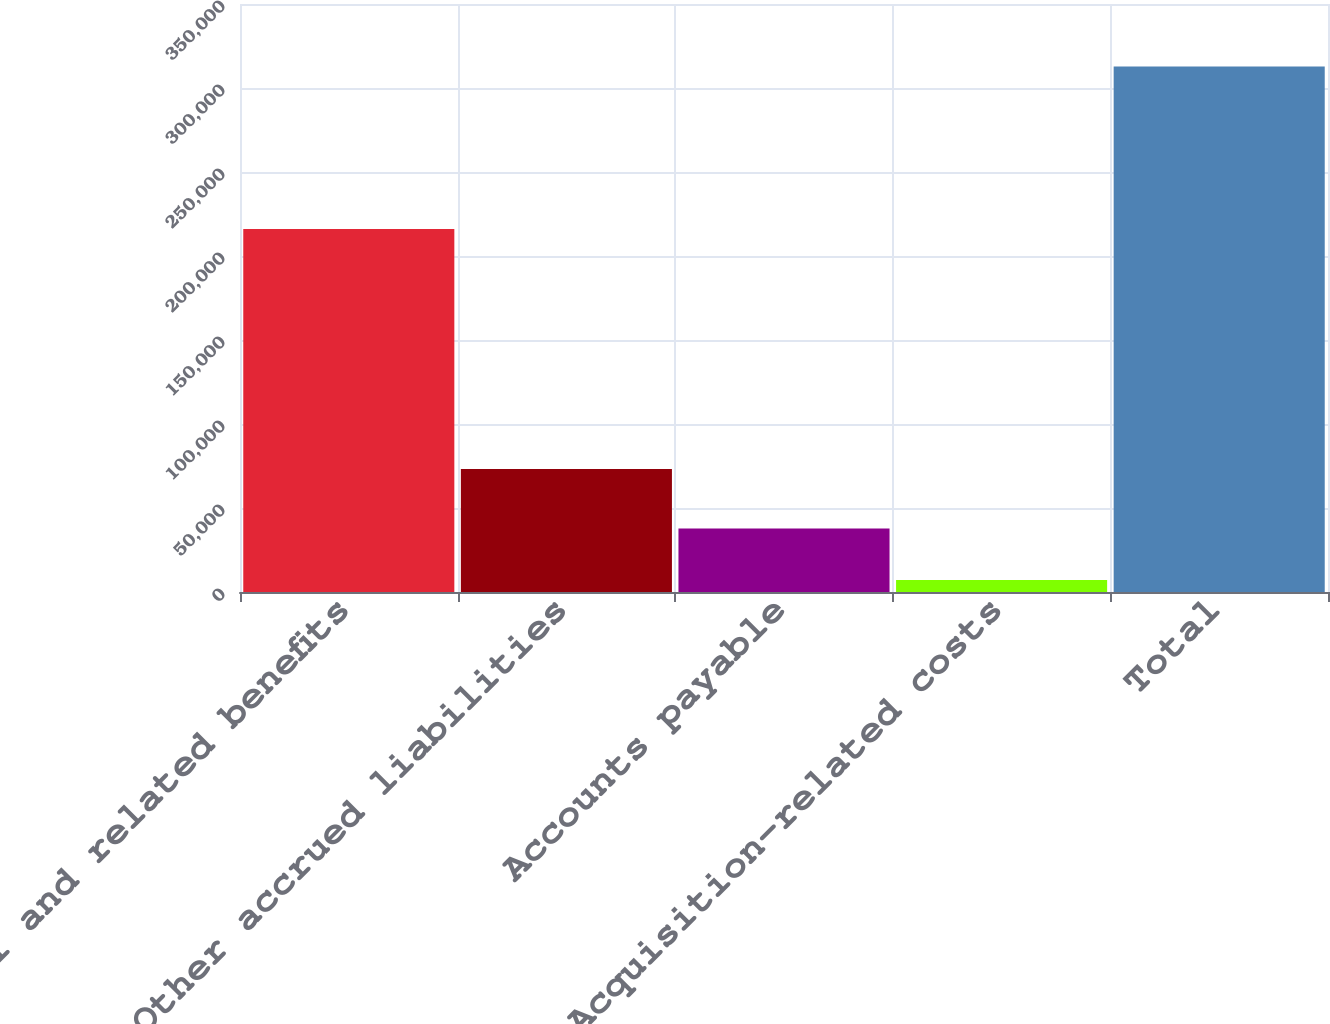<chart> <loc_0><loc_0><loc_500><loc_500><bar_chart><fcel>Payroll and related benefits<fcel>Other accrued liabilities<fcel>Accounts payable<fcel>Acquisition-related costs<fcel>Total<nl><fcel>216079<fcel>73230<fcel>37774<fcel>7210<fcel>312850<nl></chart> 